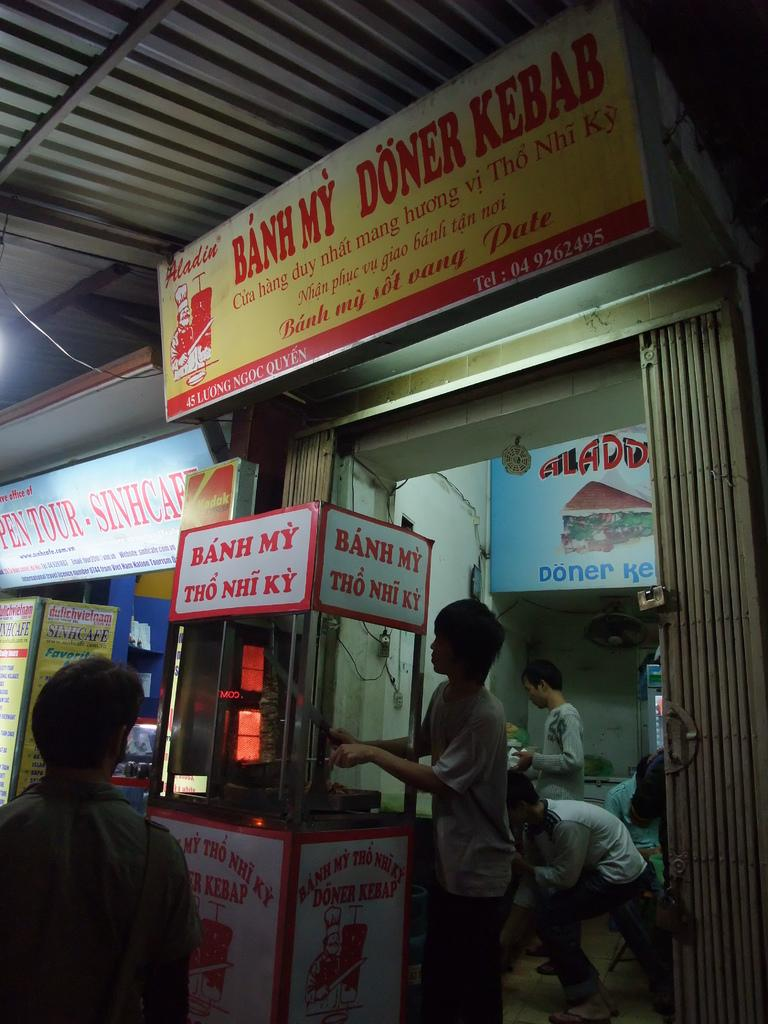What type of building is in the image? There is a small hotel in the image. What is the roof of the hotel made of? The hotel has an iron sheet roof. Can you describe the people inside the hotel? There are people standing inside the hotel. What is happening outside the hotel? There is a man walking in front of the hotel. What type of tail can be seen on the man walking in front of the hotel? There is no tail visible on the man walking in front of the hotel. What is the love interest of the people inside the hotel? The provided facts do not give any information about the love interests of the people inside the hotel. 